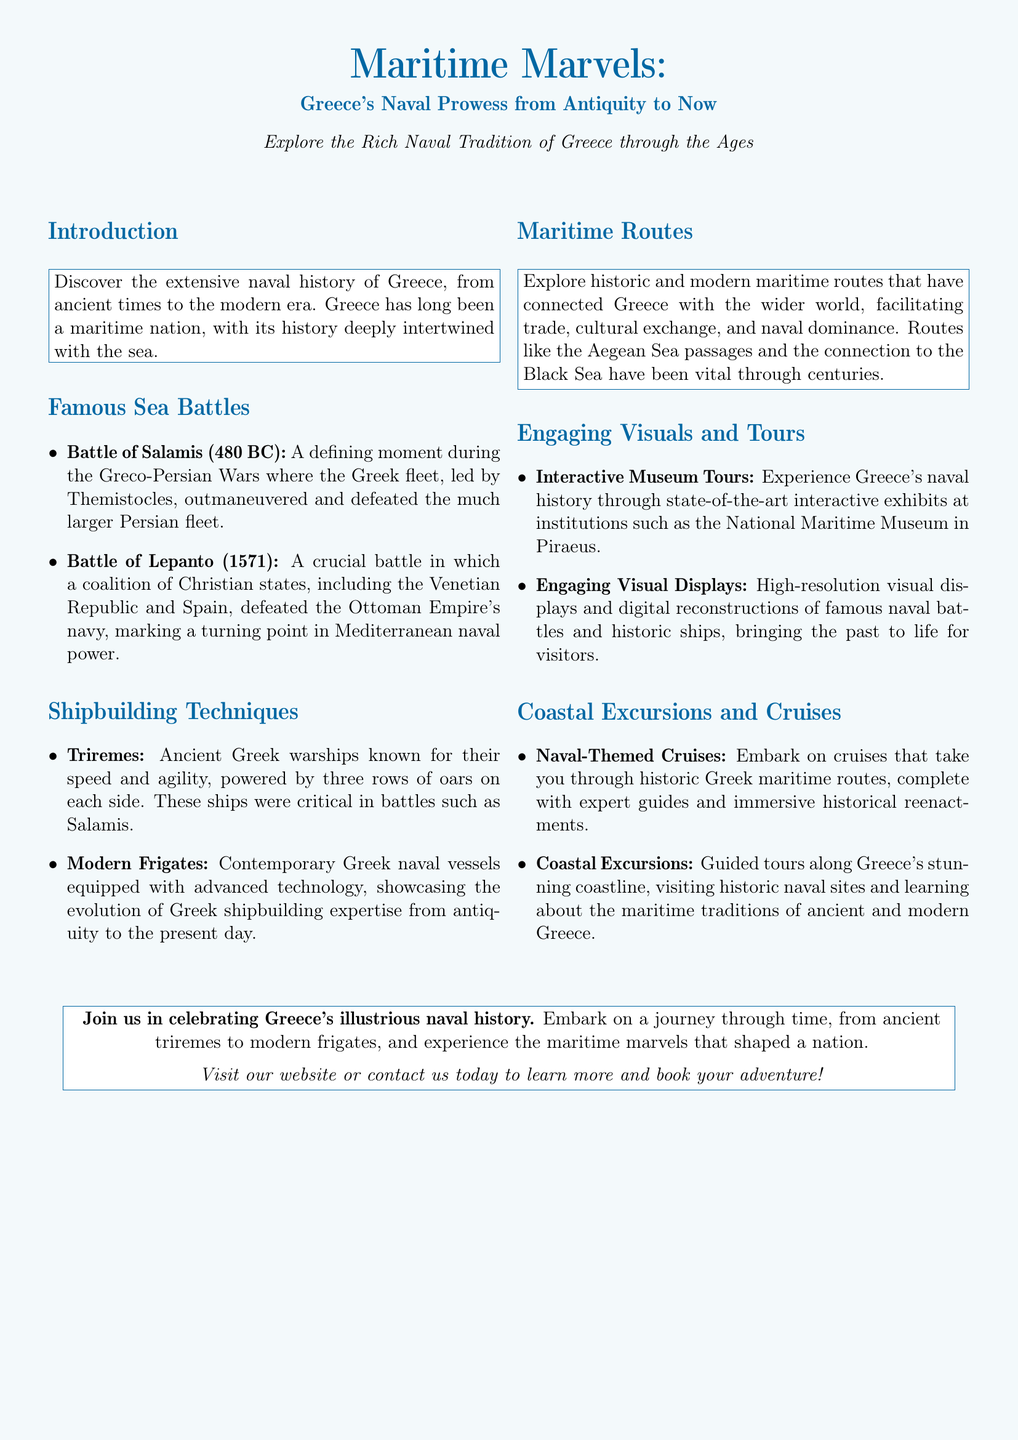What is the title of the advertisement? The title of the advertisement is prominently displayed at the beginning, highlighting the focus on Greece's naval history.
Answer: Maritime Marvels: Greece's Naval Prowess from Antiquity to Now What significant sea battle took place in 480 BC? The document lists this battle as a critical moment during the Greco-Persian Wars that showcased Greek naval strategy and victory.
Answer: Battle of Salamis What type of ancient warship is mentioned? This information is provided under “Shipbuilding Techniques,” indicating a key naval advancement of ancient Greece.
Answer: Triremes Which modern naval vessels are referenced? The document contrasts ancient and modern ships, showing progress in Greek naval technology.
Answer: Modern Frigates What historical battle occurred in 1571? The document specifies this battle as a turning point in Mediterranean naval power involving a coalition against the Ottoman navy.
Answer: Battle of Lepanto What are the coastal excursions described in the advertisement? This part of the document highlights the opportunities for guided tours and learning experiences along Greece's coastline.
Answer: Guided tours along Greece's stunning coastline What kind of experiences do the interactive museum tours offer? The document mentions the use of state-of-the-art exhibits for a deeper understanding of naval history.
Answer: State-of-the-art interactive exhibits Why is Greece described as a maritime nation? The introduction provides the reasoning behind Greece’s maritime identity, linking it to its historical context and naval activities.
Answer: Naval history intertwined with the sea What is the purpose of naval-themed cruises? This section describes the immersive nature of these cruises, which aim to educate and entertain about maritime routes.
Answer: To take you through historic Greek maritime routes 